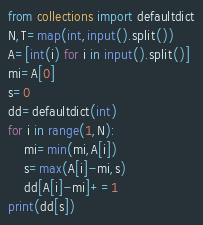Convert code to text. <code><loc_0><loc_0><loc_500><loc_500><_Python_>from collections import defaultdict
N,T=map(int,input().split())
A=[int(i) for i in input().split()]
mi=A[0]
s=0
dd=defaultdict(int)
for i in range(1,N):
    mi=min(mi,A[i])
    s=max(A[i]-mi,s)
    dd[A[i]-mi]+=1
print(dd[s])</code> 